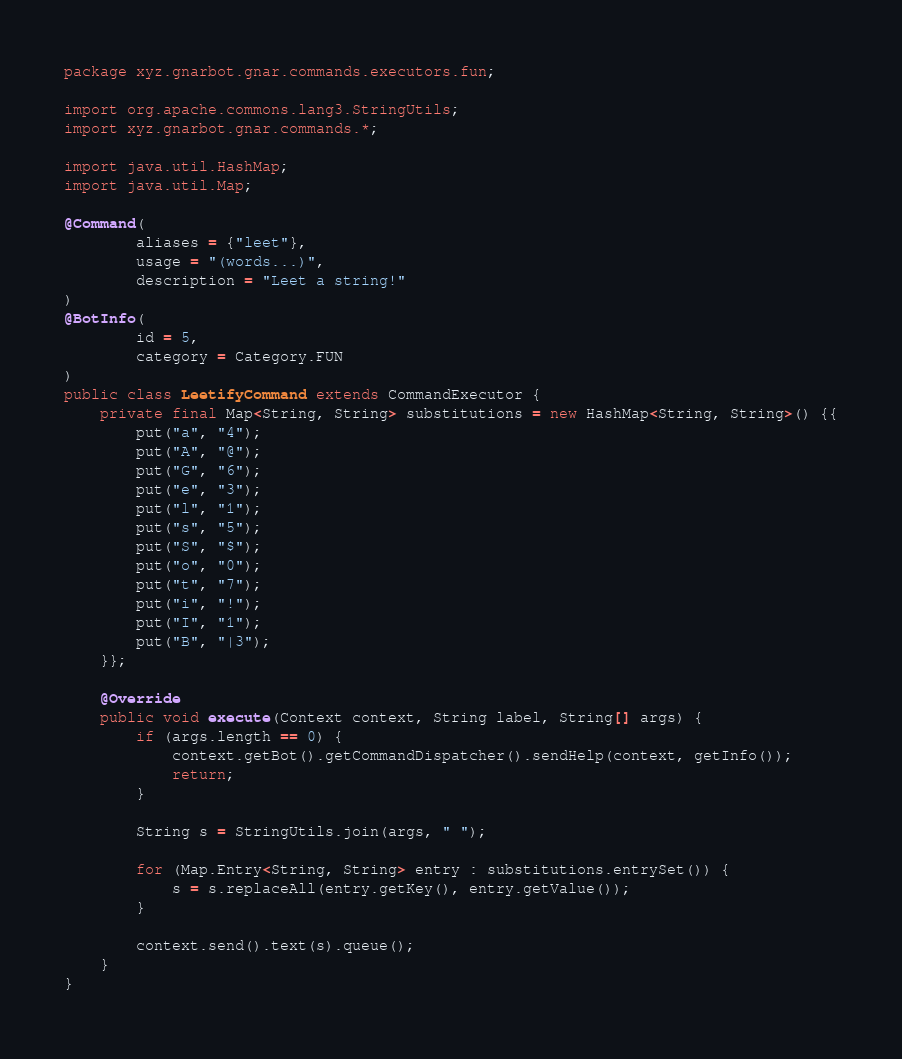Convert code to text. <code><loc_0><loc_0><loc_500><loc_500><_Java_>package xyz.gnarbot.gnar.commands.executors.fun;

import org.apache.commons.lang3.StringUtils;
import xyz.gnarbot.gnar.commands.*;

import java.util.HashMap;
import java.util.Map;

@Command(
        aliases = {"leet"},
        usage = "(words...)",
        description = "Leet a string!"
)
@BotInfo(
        id = 5,
        category = Category.FUN
)
public class LeetifyCommand extends CommandExecutor {
    private final Map<String, String> substitutions = new HashMap<String, String>() {{
        put("a", "4");
        put("A", "@");
        put("G", "6");
        put("e", "3");
        put("l", "1");
        put("s", "5");
        put("S", "$");
        put("o", "0");
        put("t", "7");
        put("i", "!");
        put("I", "1");
        put("B", "|3");
    }};

    @Override
    public void execute(Context context, String label, String[] args) {
        if (args.length == 0) {
            context.getBot().getCommandDispatcher().sendHelp(context, getInfo());
            return;
        }

        String s = StringUtils.join(args, " ");

        for (Map.Entry<String, String> entry : substitutions.entrySet()) {
            s = s.replaceAll(entry.getKey(), entry.getValue());
        }

        context.send().text(s).queue();
    }
}
</code> 